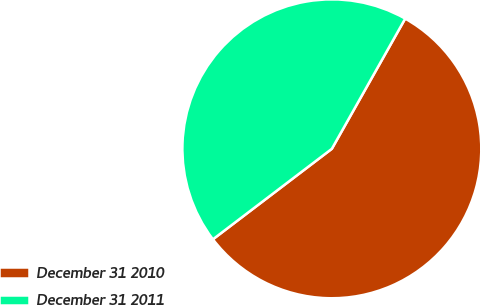<chart> <loc_0><loc_0><loc_500><loc_500><pie_chart><fcel>December 31 2010<fcel>December 31 2011<nl><fcel>56.48%<fcel>43.52%<nl></chart> 